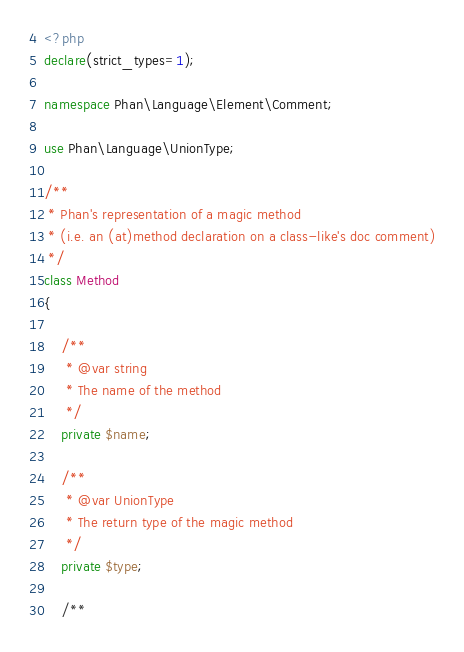Convert code to text. <code><loc_0><loc_0><loc_500><loc_500><_PHP_><?php
declare(strict_types=1);

namespace Phan\Language\Element\Comment;

use Phan\Language\UnionType;

/**
 * Phan's representation of a magic method
 * (i.e. an (at)method declaration on a class-like's doc comment)
 */
class Method
{

    /**
     * @var string
     * The name of the method
     */
    private $name;

    /**
     * @var UnionType
     * The return type of the magic method
     */
    private $type;

    /**</code> 